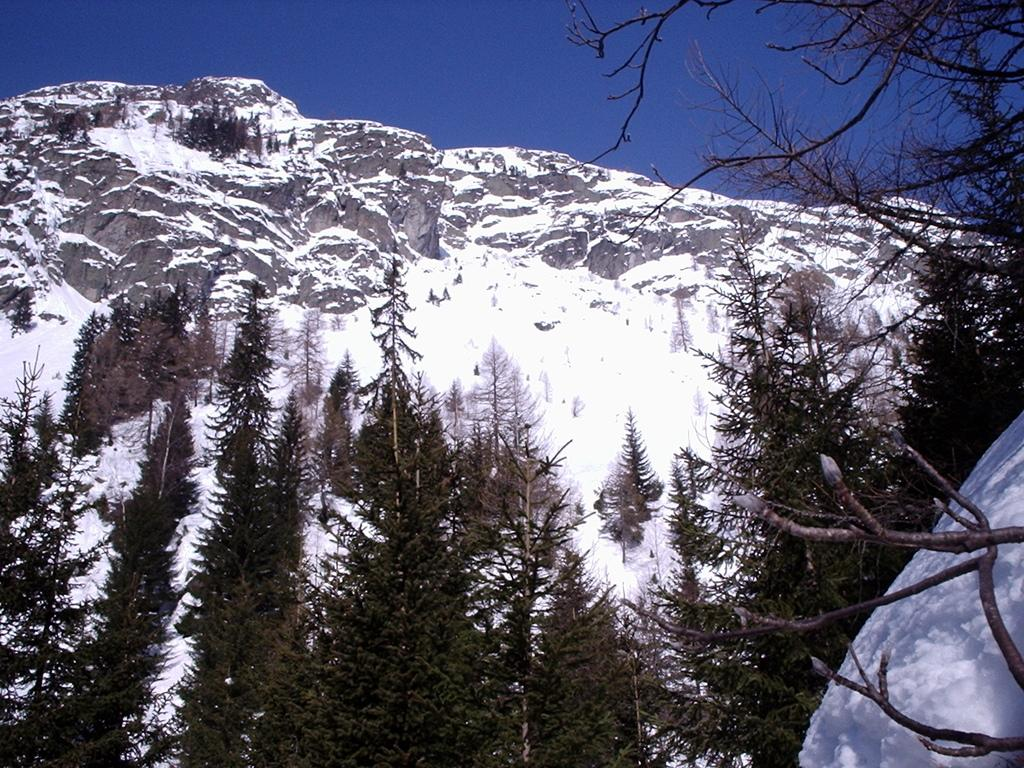What type of vegetation is present at the bottom of the image? There are trees at the bottom of the image. What natural feature is covered in snow in the image? There is snow on a mountain in the image. What part of the natural environment is visible in the image? The sky is visible in the image. What type of music can be heard playing in the background of the image? There is no music present in the image, as it is a photograph and not a video or audio recording. What type of oatmeal is being served in the image? There is no oatmeal present in the image; it features trees, snow on a mountain, and the sky. Can you tell me who the mother is in the image? There is no person or figure identified as a mother in the image. 